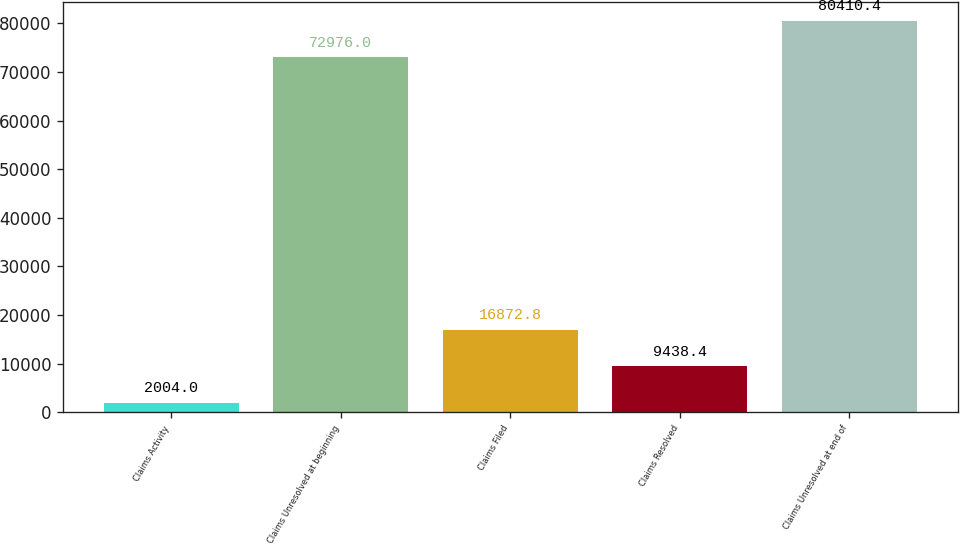Convert chart to OTSL. <chart><loc_0><loc_0><loc_500><loc_500><bar_chart><fcel>Claims Activity<fcel>Claims Unresolved at beginning<fcel>Claims Filed<fcel>Claims Resolved<fcel>Claims Unresolved at end of<nl><fcel>2004<fcel>72976<fcel>16872.8<fcel>9438.4<fcel>80410.4<nl></chart> 